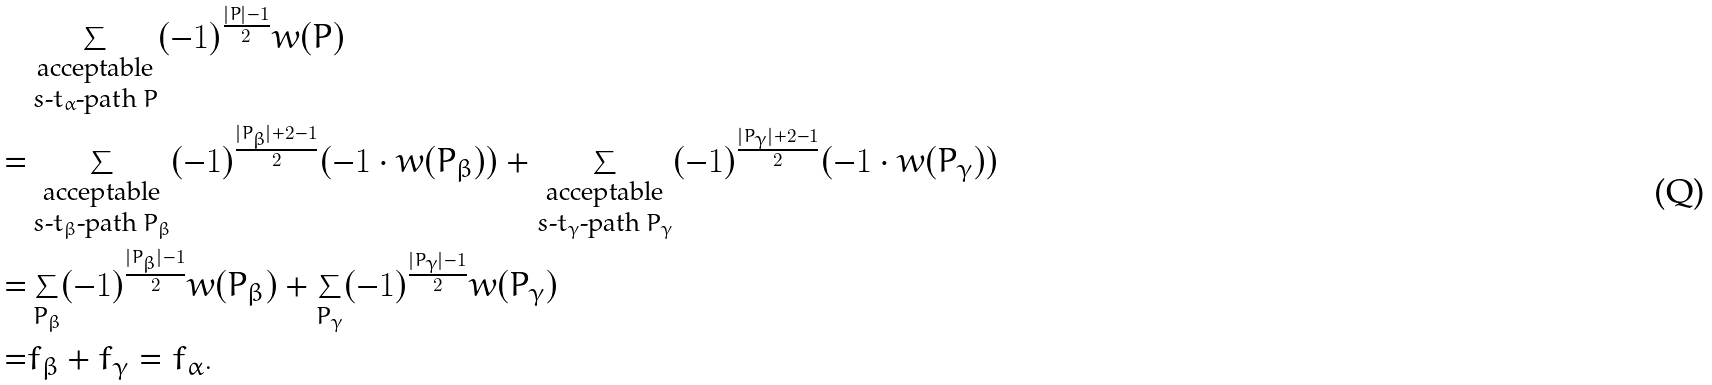Convert formula to latex. <formula><loc_0><loc_0><loc_500><loc_500>& \sum _ { \substack { \text {acceptable} \\ \text {$s$-$t_{\alpha}$-path $P$} } } ( - 1 ) ^ { \frac { | P | - 1 } { 2 } } w ( P ) \\ = & \sum _ { \substack { \text {acceptable} \\ \text {$s$-$t_{\beta}$-path $P_{\beta}$} } } ( - 1 ) ^ { \frac { | P _ { \beta } | + 2 - 1 } { 2 } } ( - 1 \cdot w ( P _ { \beta } ) ) + \sum _ { \substack { \text {acceptable} \\ \text {$s$-$t_{\gamma}$-path $P_{\gamma}$} } } ( - 1 ) ^ { \frac { | P _ { \gamma } | + 2 - 1 } { 2 } } ( - 1 \cdot w ( P _ { \gamma } ) ) \\ = & \sum _ { P _ { \beta } } ( - 1 ) ^ { \frac { | P _ { \beta } | - 1 } { 2 } } w ( P _ { \beta } ) + \sum _ { P _ { \gamma } } ( - 1 ) ^ { \frac { | P _ { \gamma } | - 1 } { 2 } } w ( P _ { \gamma } ) \\ = & f _ { \beta } + f _ { \gamma } = f _ { \alpha } .</formula> 